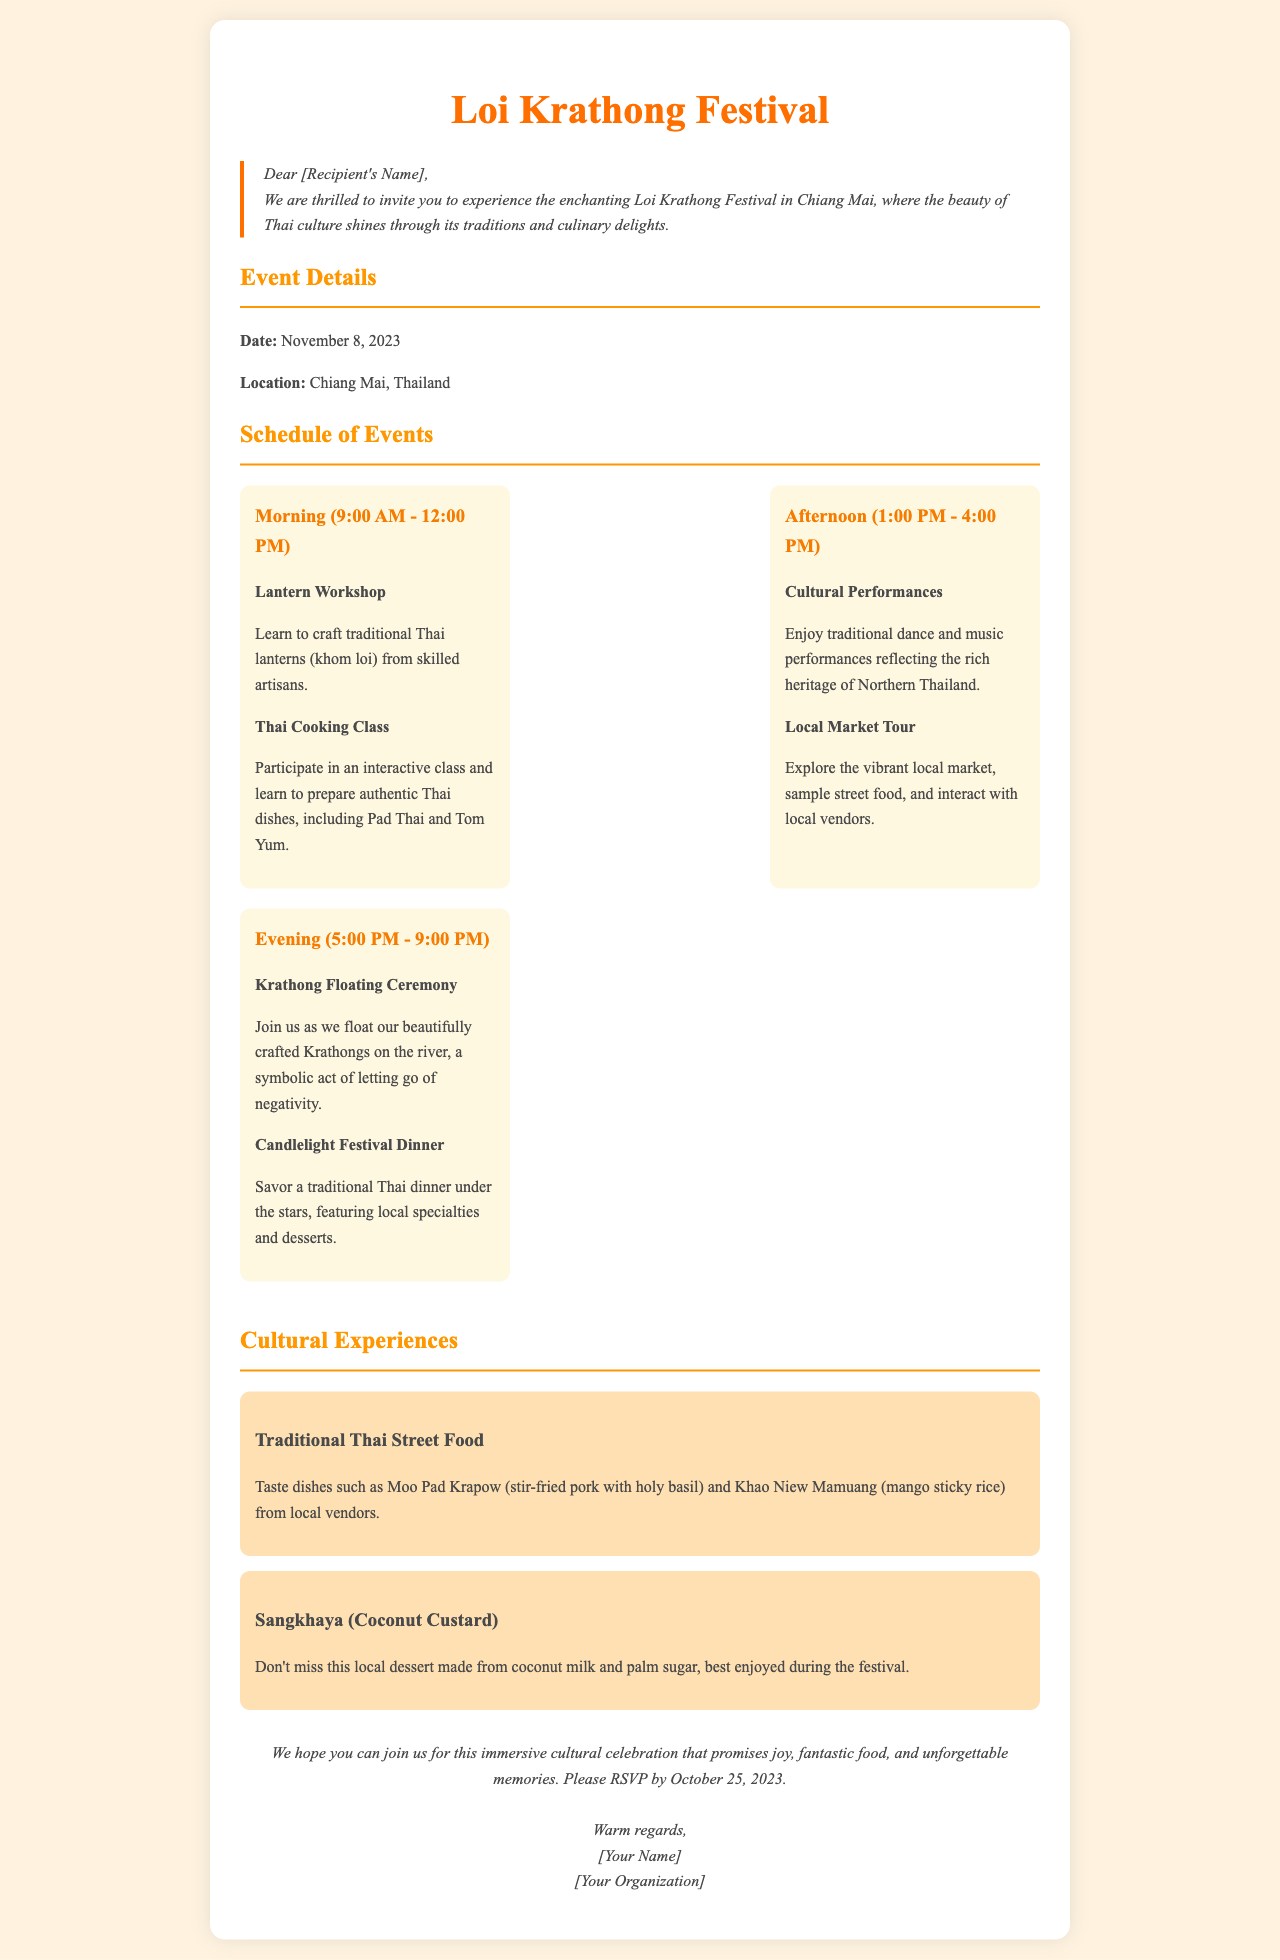What is the date of the festival? The date is specifically mentioned in the document under Event Details.
Answer: November 8, 2023 Where is the festival located? The location of the festival is stated in the Event Details section.
Answer: Chiang Mai, Thailand What is one of the activities in the morning? The morning schedule lists activities such as a Lantern Workshop and a Thai Cooking Class.
Answer: Thai Cooking Class What time does the Krathong Floating Ceremony start? The time for the Krathong Floating Ceremony is detailed in the evening schedule of events.
Answer: 5:00 PM What is one of the cultural experiences mentioned? The cultural experiences section highlights Traditional Thai Street Food and Sangkhaya.
Answer: Traditional Thai Street Food How many activities are listed for the afternoon? The afternoon schedule details two activities: Cultural Performances and Local Market Tour.
Answer: 2 What is the deadline for RSVPs? The closing section states the RSVP deadline.
Answer: October 25, 2023 Who is the letter addressed to? The introductory line in the document indicates the recipient.
Answer: [Recipient's Name] What type of dinner is offered during the festival? The evening schedule specifies a Candlelight Festival Dinner.
Answer: Candlelight Festival Dinner 